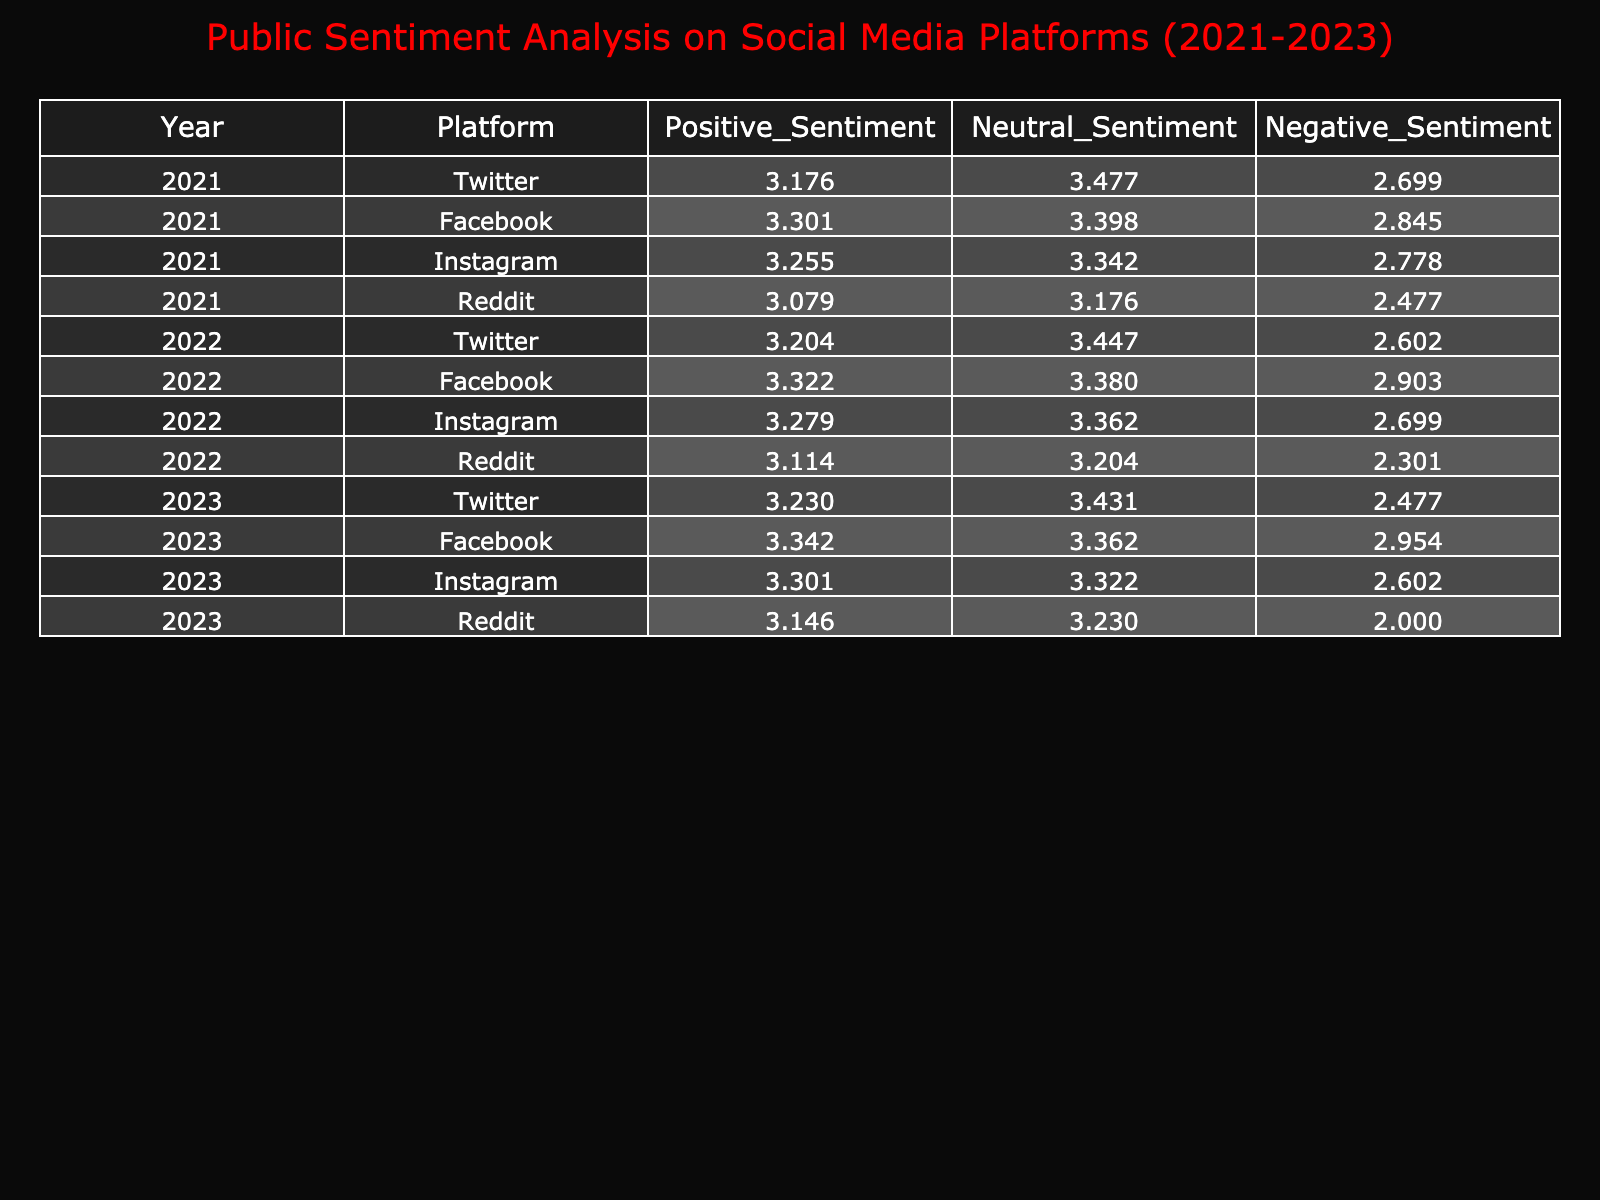What was the total positive sentiment for Facebook in 2022? The positive sentiment for Facebook in 2022 is recorded as 2100. Therefore, no calculation is needed, and the answer is simply the value stated.
Answer: 2100 What was the difference in negative sentiment on Twitter between 2021 and 2023? The negative sentiment for Twitter in 2021 is 500, and in 2023 it is 300. The difference is calculated as 500 - 300 = 200.
Answer: 200 Is the positive sentiment for Instagram in 2023 higher than in 2021? The positive sentiment for Instagram in 2023 is 2000, while in 2021 it is 1800. Since 2000 is greater than 1800, the statement is true.
Answer: Yes What is the average neutral sentiment across all platforms in 2022? For 2022, the neutral sentiments are: Twitter 2800, Facebook 2400, Instagram 2300, and Reddit 1600. Summing these gives 2800 + 2400 + 2300 + 1600 = 11100. Dividing by 4 gives an average of 11100 / 4 = 2775.
Answer: 2775 Which platform had the highest positive sentiment in 2021? Comparing the positive sentiments in 2021: Twitter 1500, Facebook 2000, Instagram 1800, Reddit 1200. The highest value is 2000 for Facebook.
Answer: Facebook What is the trend in negative sentiment for Reddit from 2021 to 2023? The negative sentiment for Reddit in 2021 is 300, in 2022 it is 200, and in 2023 it is 100. The values decrease from 300 to 100, indicating a downward trend in negative sentiment over the three years.
Answer: Downward trend What is the sum of positive sentiments for all platforms in 2023? The positive sentiments for 2023 are: Twitter 1700, Facebook 2200, Instagram 2000, and Reddit 1400. The sum is calculated as 1700 + 2200 + 2000 + 1400 = 7300.
Answer: 7300 In which year did Twitter experience its lowest negative sentiment? The negative sentiments for Twitter are: 2021 - 500, 2022 - 400, and 2023 - 300. The lowest value is 300, occurring in 2023.
Answer: 2023 How does the positive sentiment for Facebook in 2021 compare to that in 2022? The positive sentiment for Facebook in 2021 is 2000, and in 2022, it is 2100. 2100 is greater than 2000, indicating that the sentiment increased.
Answer: Increased 